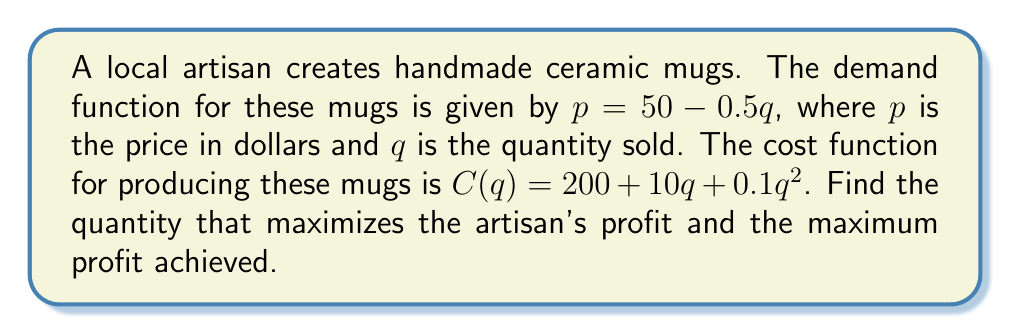Teach me how to tackle this problem. 1. The profit function $P(q)$ is revenue minus cost:
   $P(q) = pq - C(q)$
   $P(q) = (50 - 0.5q)q - (200 + 10q + 0.1q^2)$
   $P(q) = 50q - 0.5q^2 - 200 - 10q - 0.1q^2$
   $P(q) = -0.6q^2 + 40q - 200$

2. To find the maximum profit, we need to find where $\frac{dP}{dq} = 0$:
   $\frac{dP}{dq} = -1.2q + 40$

3. Set this equal to zero and solve for $q$:
   $-1.2q + 40 = 0$
   $-1.2q = -40$
   $q = \frac{40}{1.2} = \frac{100}{3} \approx 33.33$

4. To confirm this is a maximum, check the second derivative:
   $\frac{d^2P}{dq^2} = -1.2 < 0$, confirming a maximum.

5. The optimal quantity is $\frac{100}{3}$ mugs.

6. To find the maximum profit, substitute this quantity back into the profit function:
   $P(\frac{100}{3}) = -0.6(\frac{100}{3})^2 + 40(\frac{100}{3}) - 200$
   $= -0.6(\frac{10000}{9}) + \frac{4000}{3} - 200$
   $= -\frac{6000}{9} + \frac{4000}{3} - 200$
   $= -666.67 + 1333.33 - 200$
   $= 466.67$
Answer: Optimal quantity: $\frac{100}{3}$ mugs; Maximum profit: $\$466.67$ 